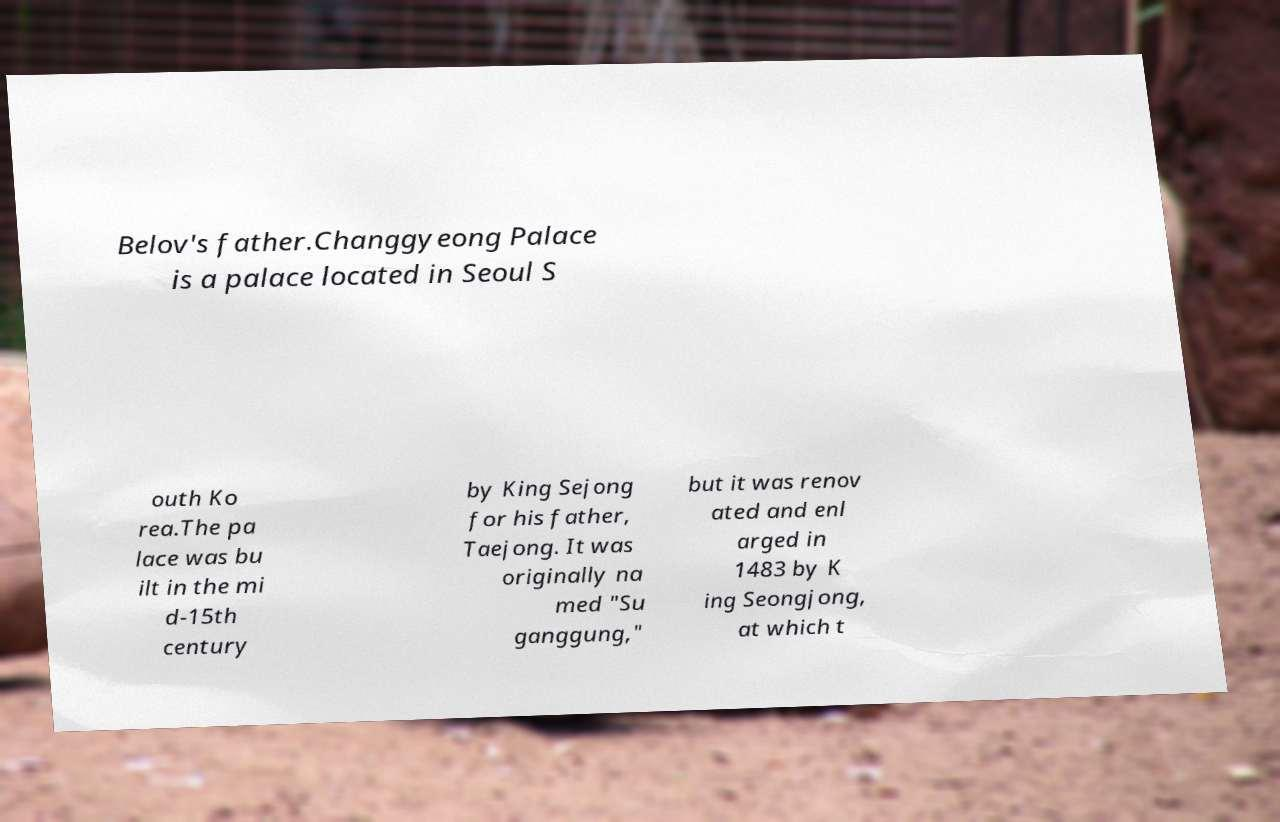Could you extract and type out the text from this image? Belov's father.Changgyeong Palace is a palace located in Seoul S outh Ko rea.The pa lace was bu ilt in the mi d-15th century by King Sejong for his father, Taejong. It was originally na med "Su ganggung," but it was renov ated and enl arged in 1483 by K ing Seongjong, at which t 